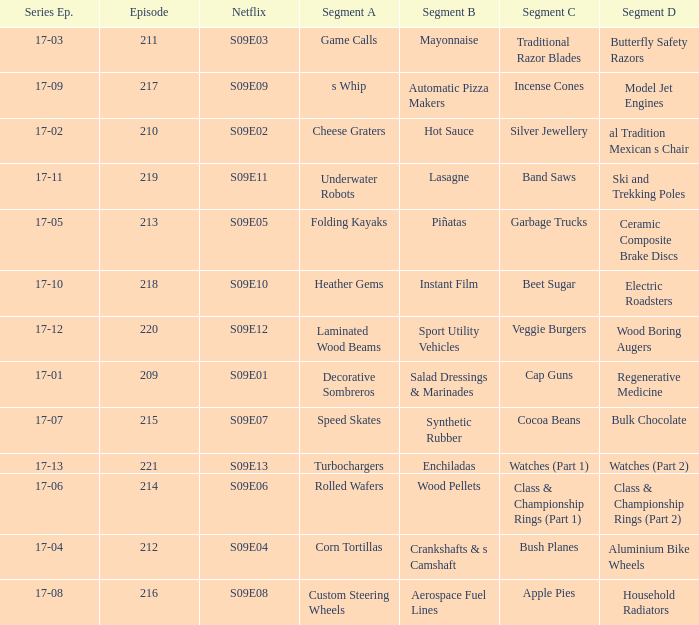Could you help me parse every detail presented in this table? {'header': ['Series Ep.', 'Episode', 'Netflix', 'Segment A', 'Segment B', 'Segment C', 'Segment D'], 'rows': [['17-03', '211', 'S09E03', 'Game Calls', 'Mayonnaise', 'Traditional Razor Blades', 'Butterfly Safety Razors'], ['17-09', '217', 'S09E09', 's Whip', 'Automatic Pizza Makers', 'Incense Cones', 'Model Jet Engines'], ['17-02', '210', 'S09E02', 'Cheese Graters', 'Hot Sauce', 'Silver Jewellery', 'al Tradition Mexican s Chair'], ['17-11', '219', 'S09E11', 'Underwater Robots', 'Lasagne', 'Band Saws', 'Ski and Trekking Poles'], ['17-05', '213', 'S09E05', 'Folding Kayaks', 'Piñatas', 'Garbage Trucks', 'Ceramic Composite Brake Discs'], ['17-10', '218', 'S09E10', 'Heather Gems', 'Instant Film', 'Beet Sugar', 'Electric Roadsters'], ['17-12', '220', 'S09E12', 'Laminated Wood Beams', 'Sport Utility Vehicles', 'Veggie Burgers', 'Wood Boring Augers'], ['17-01', '209', 'S09E01', 'Decorative Sombreros', 'Salad Dressings & Marinades', 'Cap Guns', 'Regenerative Medicine'], ['17-07', '215', 'S09E07', 'Speed Skates', 'Synthetic Rubber', 'Cocoa Beans', 'Bulk Chocolate'], ['17-13', '221', 'S09E13', 'Turbochargers', 'Enchiladas', 'Watches (Part 1)', 'Watches (Part 2)'], ['17-06', '214', 'S09E06', 'Rolled Wafers', 'Wood Pellets', 'Class & Championship Rings (Part 1)', 'Class & Championship Rings (Part 2)'], ['17-04', '212', 'S09E04', 'Corn Tortillas', 'Crankshafts & s Camshaft', 'Bush Planes', 'Aluminium Bike Wheels'], ['17-08', '216', 'S09E08', 'Custom Steering Wheels', 'Aerospace Fuel Lines', 'Apple Pies', 'Household Radiators']]} Segment A of heather gems is what netflix episode? S09E10. 